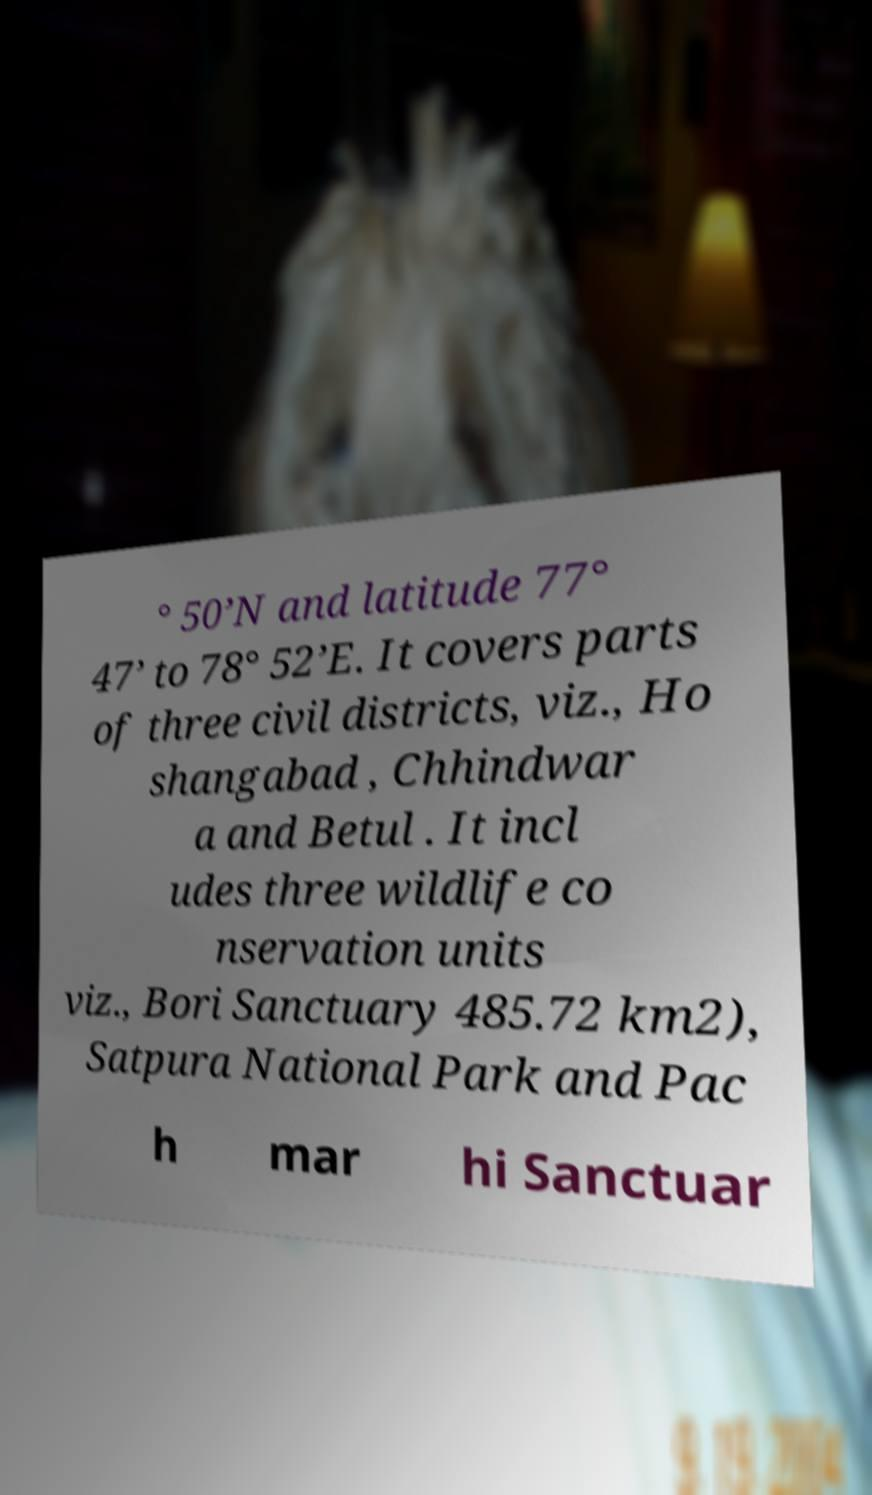Please read and relay the text visible in this image. What does it say? ° 50’N and latitude 77° 47’ to 78° 52’E. It covers parts of three civil districts, viz., Ho shangabad , Chhindwar a and Betul . It incl udes three wildlife co nservation units viz., Bori Sanctuary 485.72 km2), Satpura National Park and Pac h mar hi Sanctuar 